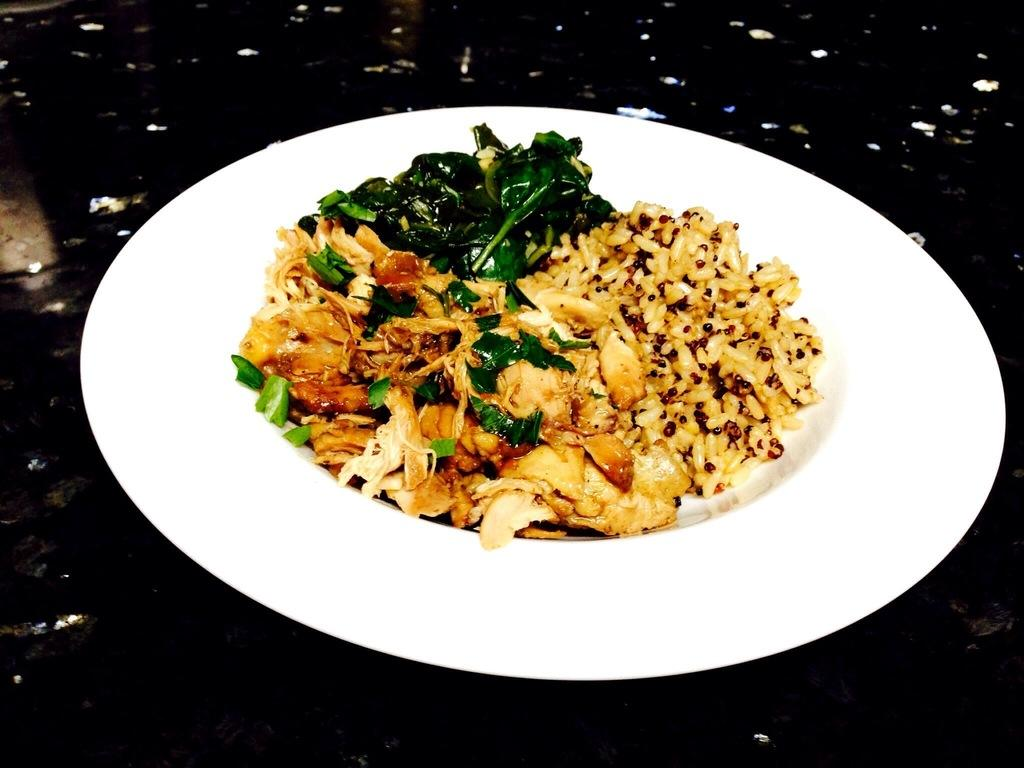What is the main subject of the image? There is a food item in the image. What can be observed about the plate on which the food item is placed? The plate is in the middle of the image and is white in color. What type of vegetable is being used as a chalk substitute in the image? There is no vegetable or chalk present in the image. 